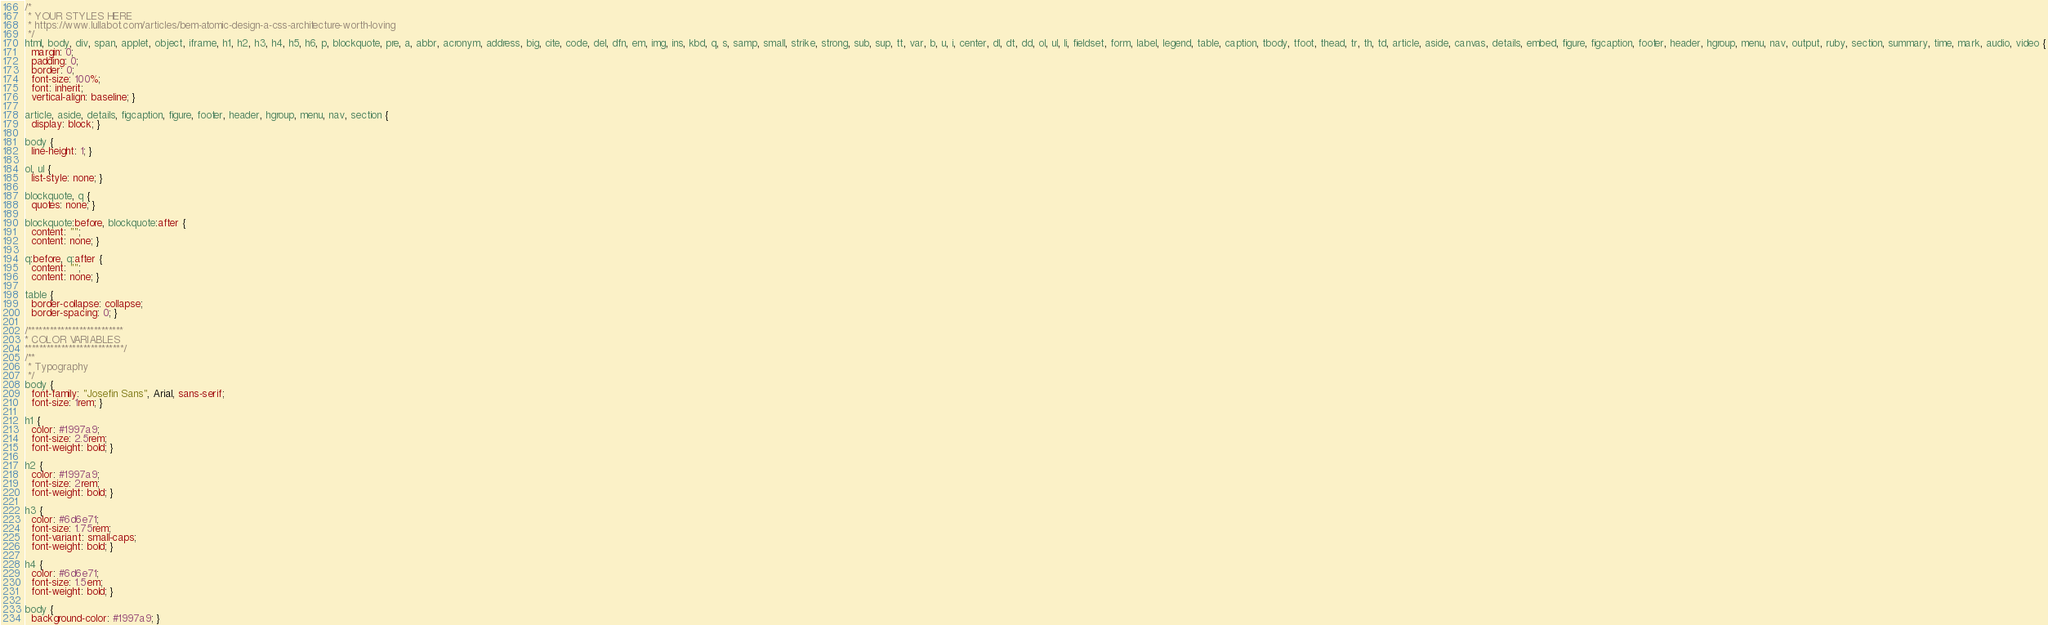Convert code to text. <code><loc_0><loc_0><loc_500><loc_500><_CSS_>/*
 * YOUR STYLES HERE
 * https://www.lullabot.com/articles/bem-atomic-design-a-css-architecture-worth-loving
 */
html, body, div, span, applet, object, iframe, h1, h2, h3, h4, h5, h6, p, blockquote, pre, a, abbr, acronym, address, big, cite, code, del, dfn, em, img, ins, kbd, q, s, samp, small, strike, strong, sub, sup, tt, var, b, u, i, center, dl, dt, dd, ol, ul, li, fieldset, form, label, legend, table, caption, tbody, tfoot, thead, tr, th, td, article, aside, canvas, details, embed, figure, figcaption, footer, header, hgroup, menu, nav, output, ruby, section, summary, time, mark, audio, video {
  margin: 0;
  padding: 0;
  border: 0;
  font-size: 100%;
  font: inherit;
  vertical-align: baseline; }

article, aside, details, figcaption, figure, footer, header, hgroup, menu, nav, section {
  display: block; }

body {
  line-height: 1; }

ol, ul {
  list-style: none; }

blockquote, q {
  quotes: none; }

blockquote:before, blockquote:after {
  content: "";
  content: none; }

q:before, q:after {
  content: "";
  content: none; }

table {
  border-collapse: collapse;
  border-spacing: 0; }

/**************************
* COLOR VARIABLES
***************************/
/**
 * Typography
 */
body {
  font-family: "Josefin Sans", Arial, sans-serif;
  font-size: 1rem; }

h1 {
  color: #1997a9;
  font-size: 2.5rem;
  font-weight: bold; }

h2 {
  color: #1997a9;
  font-size: 2rem;
  font-weight: bold; }

h3 {
  color: #6d6e71;
  font-size: 1.75rem;
  font-variant: small-caps;
  font-weight: bold; }

h4 {
  color: #6d6e71;
  font-size: 1.5em;
  font-weight: bold; }

body {
  background-color: #1997a9; }
</code> 